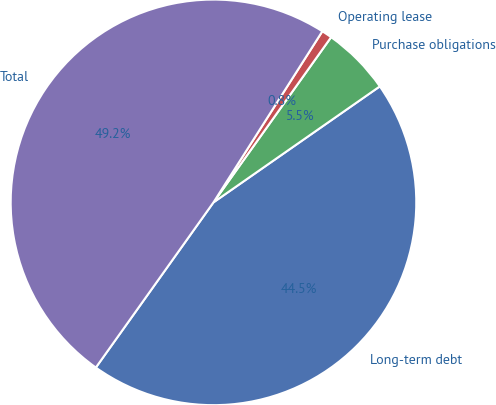Convert chart. <chart><loc_0><loc_0><loc_500><loc_500><pie_chart><fcel>Long-term debt<fcel>Purchase obligations<fcel>Operating lease<fcel>Total<nl><fcel>44.54%<fcel>5.46%<fcel>0.83%<fcel>49.17%<nl></chart> 